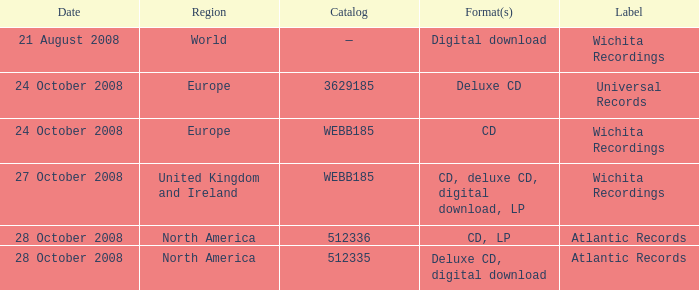Which catalog value has a region of world? —. 